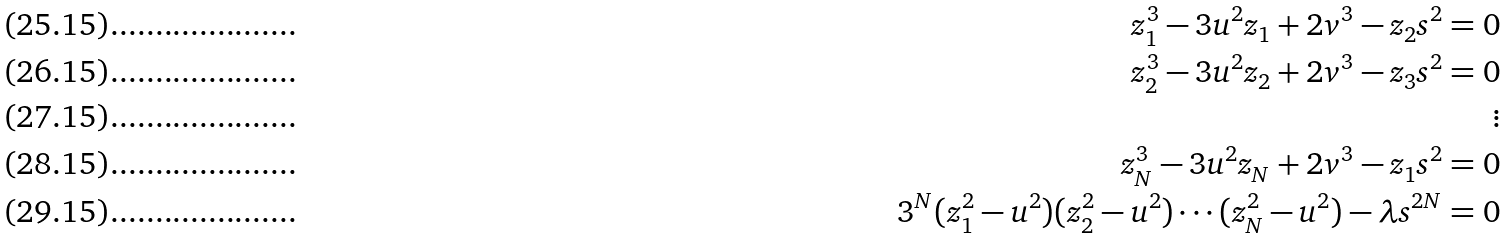Convert formula to latex. <formula><loc_0><loc_0><loc_500><loc_500>z _ { 1 } ^ { 3 } - 3 u ^ { 2 } z _ { 1 } + 2 v ^ { 3 } - z _ { 2 } s ^ { 2 } = 0 \\ z _ { 2 } ^ { 3 } - 3 u ^ { 2 } z _ { 2 } + 2 v ^ { 3 } - z _ { 3 } s ^ { 2 } = 0 \\ \vdots \\ z _ { N } ^ { 3 } - 3 u ^ { 2 } z _ { N } + 2 v ^ { 3 } - z _ { 1 } s ^ { 2 } = 0 \\ 3 ^ { N } ( z _ { 1 } ^ { 2 } - u ^ { 2 } ) ( z _ { 2 } ^ { 2 } - u ^ { 2 } ) \cdots ( z _ { N } ^ { 2 } - u ^ { 2 } ) - \lambda s ^ { 2 N } = 0</formula> 